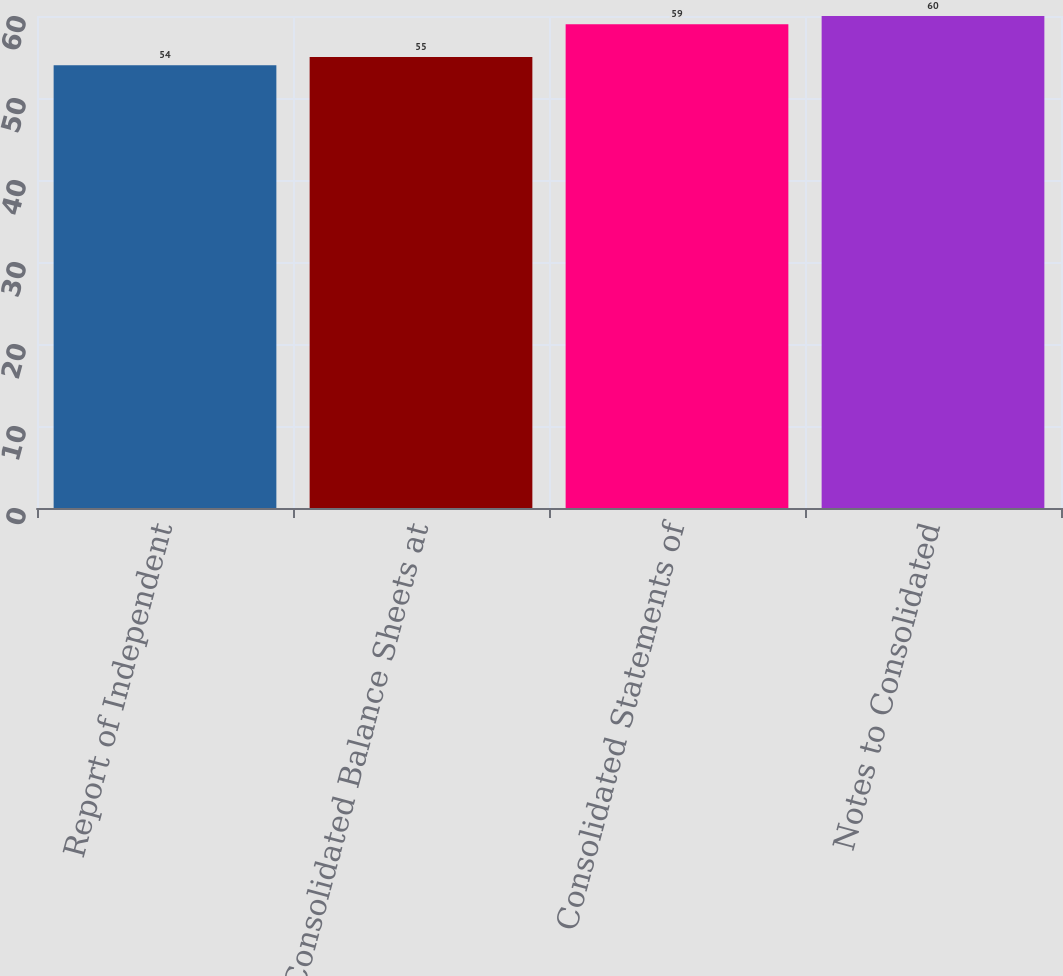Convert chart. <chart><loc_0><loc_0><loc_500><loc_500><bar_chart><fcel>Report of Independent<fcel>Consolidated Balance Sheets at<fcel>Consolidated Statements of<fcel>Notes to Consolidated<nl><fcel>54<fcel>55<fcel>59<fcel>60<nl></chart> 